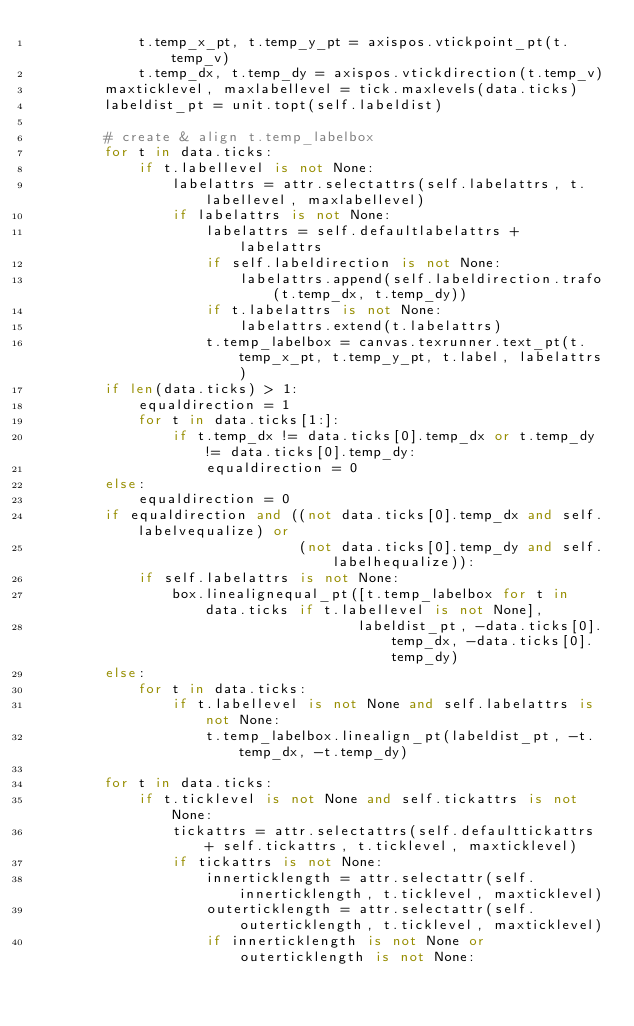<code> <loc_0><loc_0><loc_500><loc_500><_Python_>            t.temp_x_pt, t.temp_y_pt = axispos.vtickpoint_pt(t.temp_v)
            t.temp_dx, t.temp_dy = axispos.vtickdirection(t.temp_v)
        maxticklevel, maxlabellevel = tick.maxlevels(data.ticks)
        labeldist_pt = unit.topt(self.labeldist)

        # create & align t.temp_labelbox
        for t in data.ticks:
            if t.labellevel is not None:
                labelattrs = attr.selectattrs(self.labelattrs, t.labellevel, maxlabellevel)
                if labelattrs is not None:
                    labelattrs = self.defaultlabelattrs + labelattrs
                    if self.labeldirection is not None:
                        labelattrs.append(self.labeldirection.trafo(t.temp_dx, t.temp_dy))
                    if t.labelattrs is not None:
                        labelattrs.extend(t.labelattrs)
                    t.temp_labelbox = canvas.texrunner.text_pt(t.temp_x_pt, t.temp_y_pt, t.label, labelattrs)
        if len(data.ticks) > 1:
            equaldirection = 1
            for t in data.ticks[1:]:
                if t.temp_dx != data.ticks[0].temp_dx or t.temp_dy != data.ticks[0].temp_dy:
                    equaldirection = 0
        else:
            equaldirection = 0
        if equaldirection and ((not data.ticks[0].temp_dx and self.labelvequalize) or
                               (not data.ticks[0].temp_dy and self.labelhequalize)):
            if self.labelattrs is not None:
                box.linealignequal_pt([t.temp_labelbox for t in data.ticks if t.labellevel is not None],
                                      labeldist_pt, -data.ticks[0].temp_dx, -data.ticks[0].temp_dy)
        else:
            for t in data.ticks:
                if t.labellevel is not None and self.labelattrs is not None:
                    t.temp_labelbox.linealign_pt(labeldist_pt, -t.temp_dx, -t.temp_dy)

        for t in data.ticks:
            if t.ticklevel is not None and self.tickattrs is not None:
                tickattrs = attr.selectattrs(self.defaulttickattrs + self.tickattrs, t.ticklevel, maxticklevel)
                if tickattrs is not None:
                    innerticklength = attr.selectattr(self.innerticklength, t.ticklevel, maxticklevel)
                    outerticklength = attr.selectattr(self.outerticklength, t.ticklevel, maxticklevel)
                    if innerticklength is not None or outerticklength is not None:</code> 